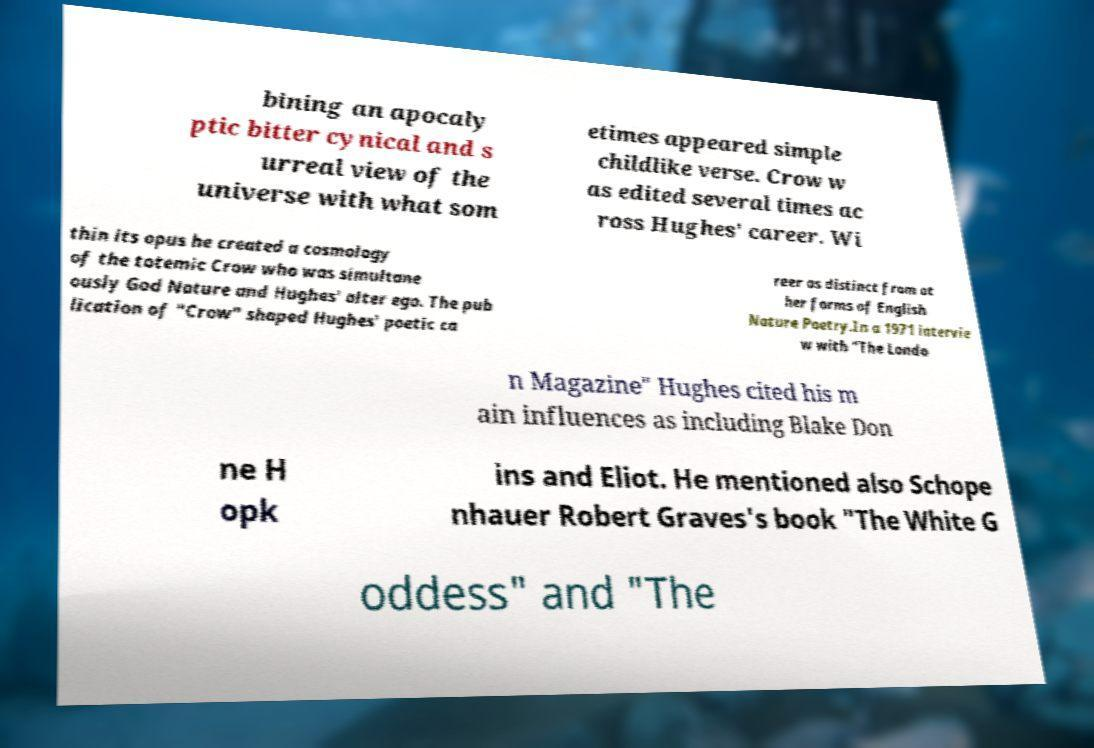For documentation purposes, I need the text within this image transcribed. Could you provide that? bining an apocaly ptic bitter cynical and s urreal view of the universe with what som etimes appeared simple childlike verse. Crow w as edited several times ac ross Hughes' career. Wi thin its opus he created a cosmology of the totemic Crow who was simultane ously God Nature and Hughes' alter ego. The pub lication of "Crow" shaped Hughes' poetic ca reer as distinct from ot her forms of English Nature Poetry.In a 1971 intervie w with "The Londo n Magazine" Hughes cited his m ain influences as including Blake Don ne H opk ins and Eliot. He mentioned also Schope nhauer Robert Graves's book "The White G oddess" and "The 